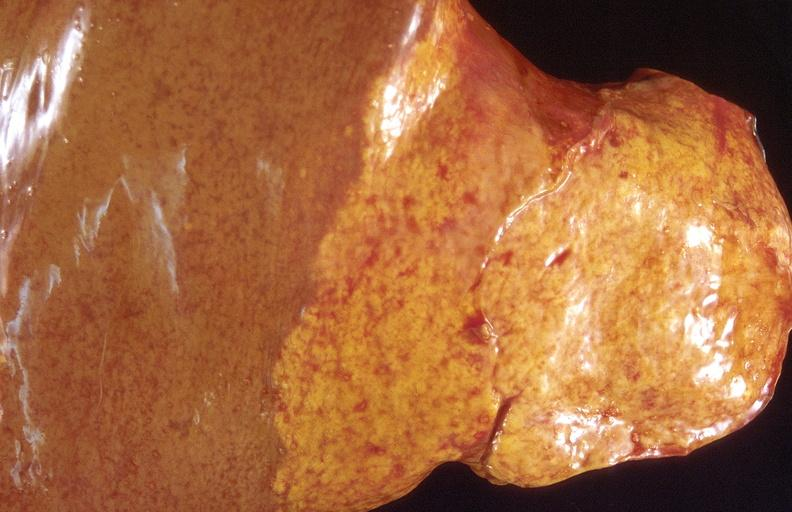s typical tuberculous exudate present?
Answer the question using a single word or phrase. No 